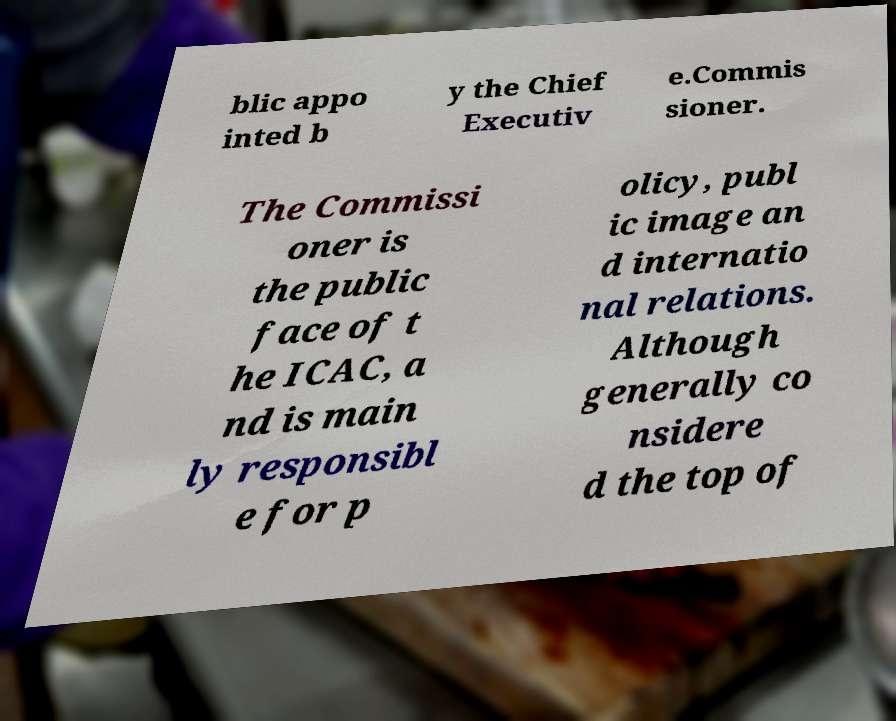Can you accurately transcribe the text from the provided image for me? blic appo inted b y the Chief Executiv e.Commis sioner. The Commissi oner is the public face of t he ICAC, a nd is main ly responsibl e for p olicy, publ ic image an d internatio nal relations. Although generally co nsidere d the top of 